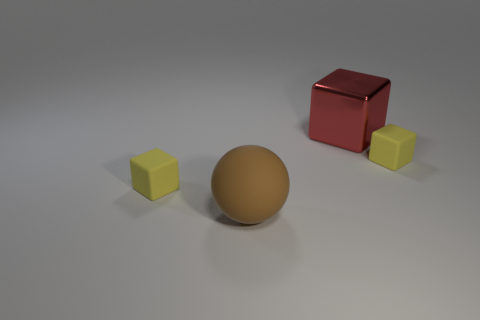Add 1 cubes. How many objects exist? 5 Subtract all spheres. How many objects are left? 3 Subtract all tiny yellow metal things. Subtract all small cubes. How many objects are left? 2 Add 4 small yellow things. How many small yellow things are left? 6 Add 4 blocks. How many blocks exist? 7 Subtract 0 green blocks. How many objects are left? 4 